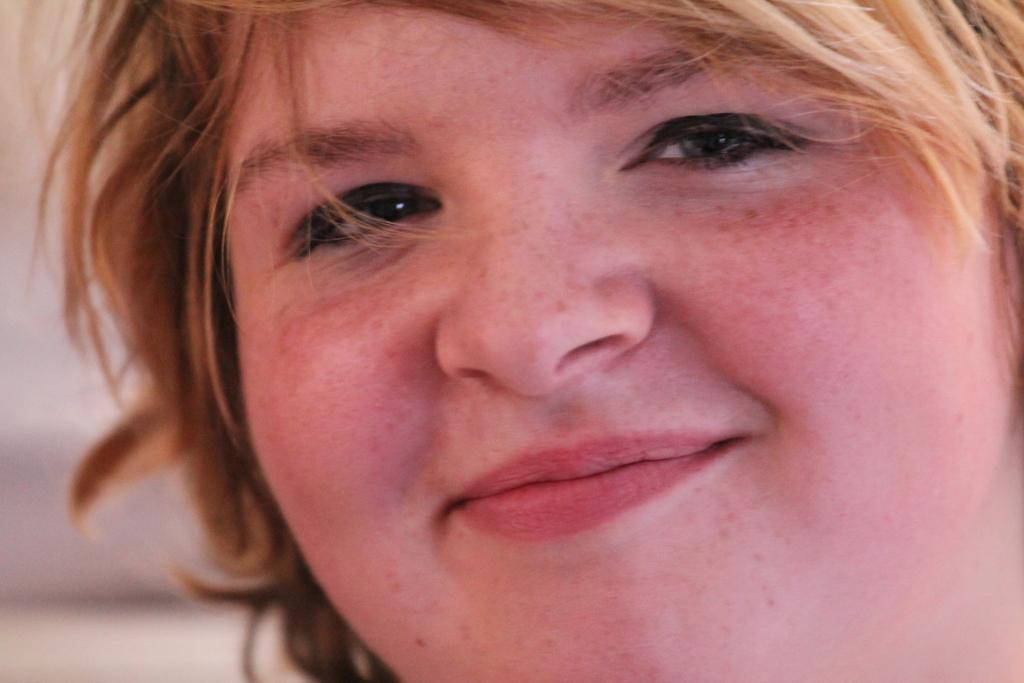What is present in the image? There is a person in the image. How is the person's expression in the image? The person is smiling. How many spiders are crawling on the person's face in the image? There are no spiders present in the image; the person is simply smiling. 